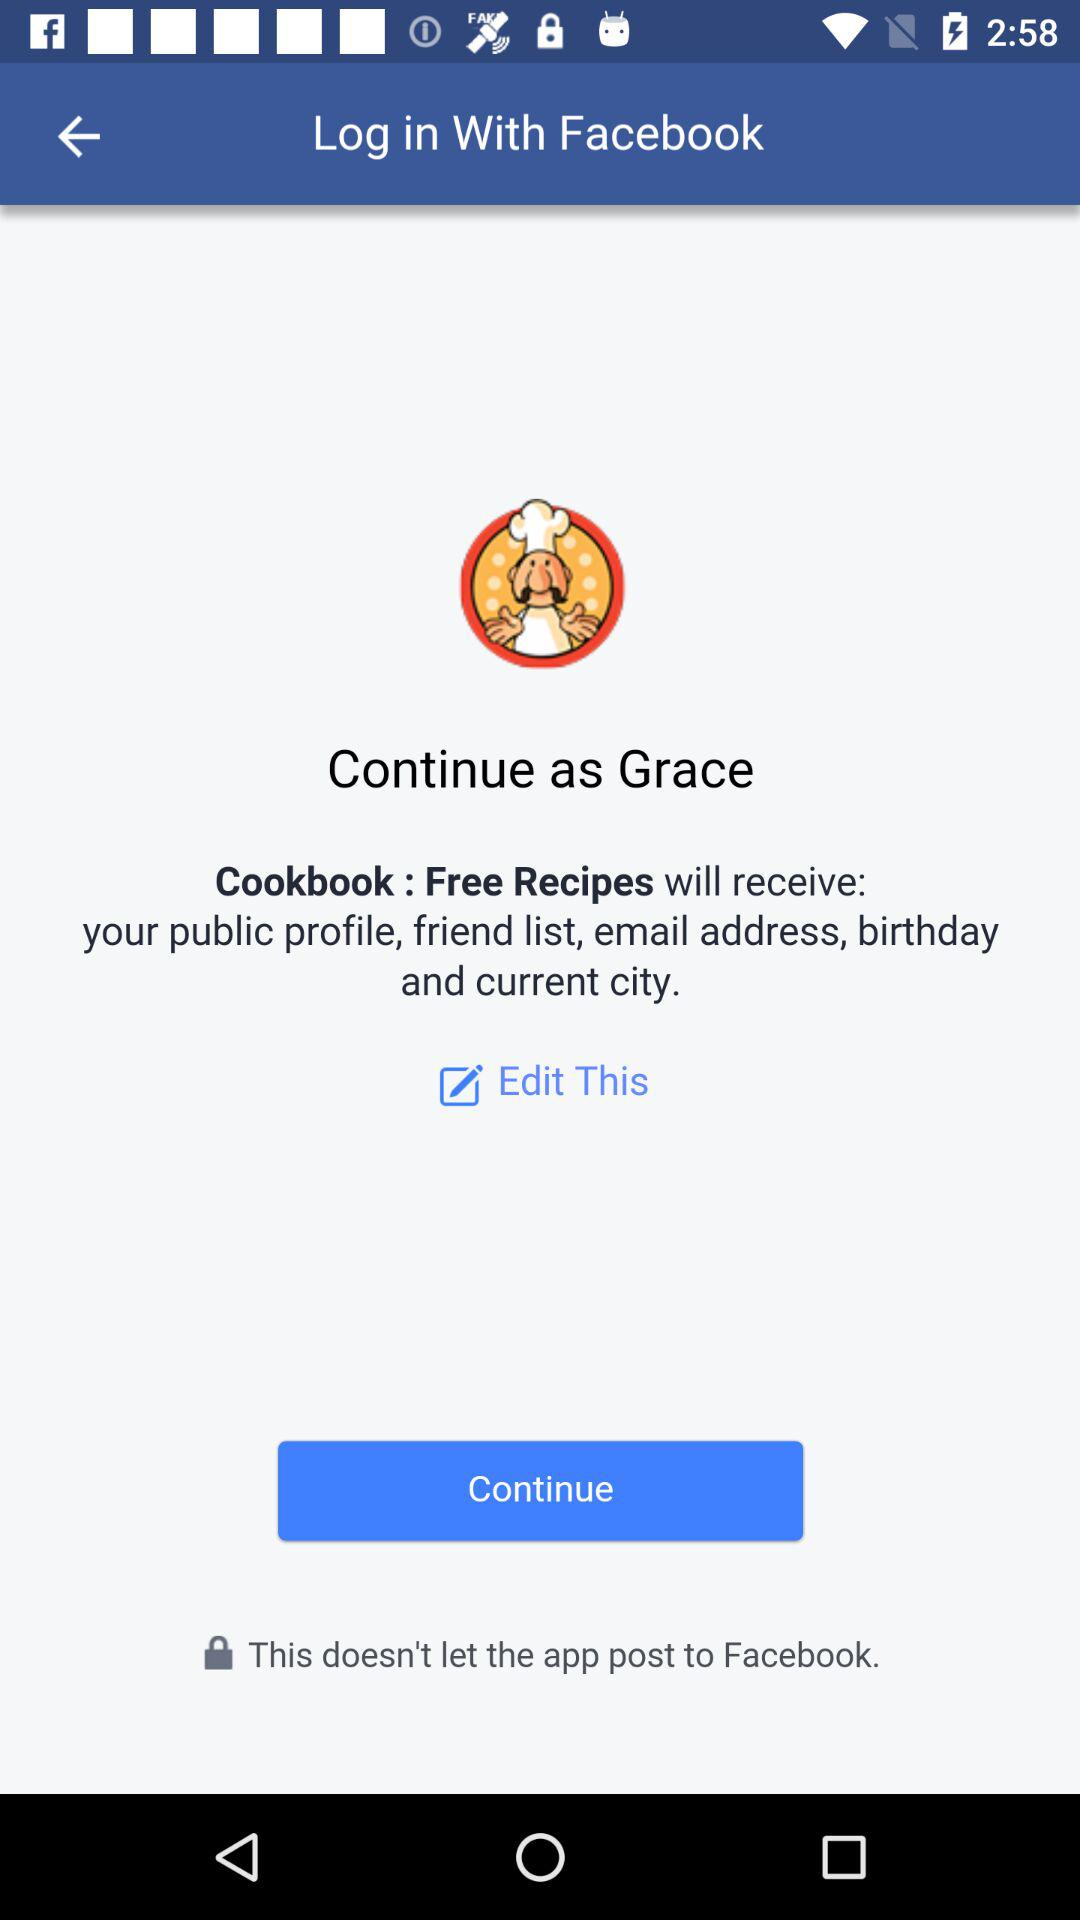Through what account log in can be done? Log in can be done through "Facebook". 